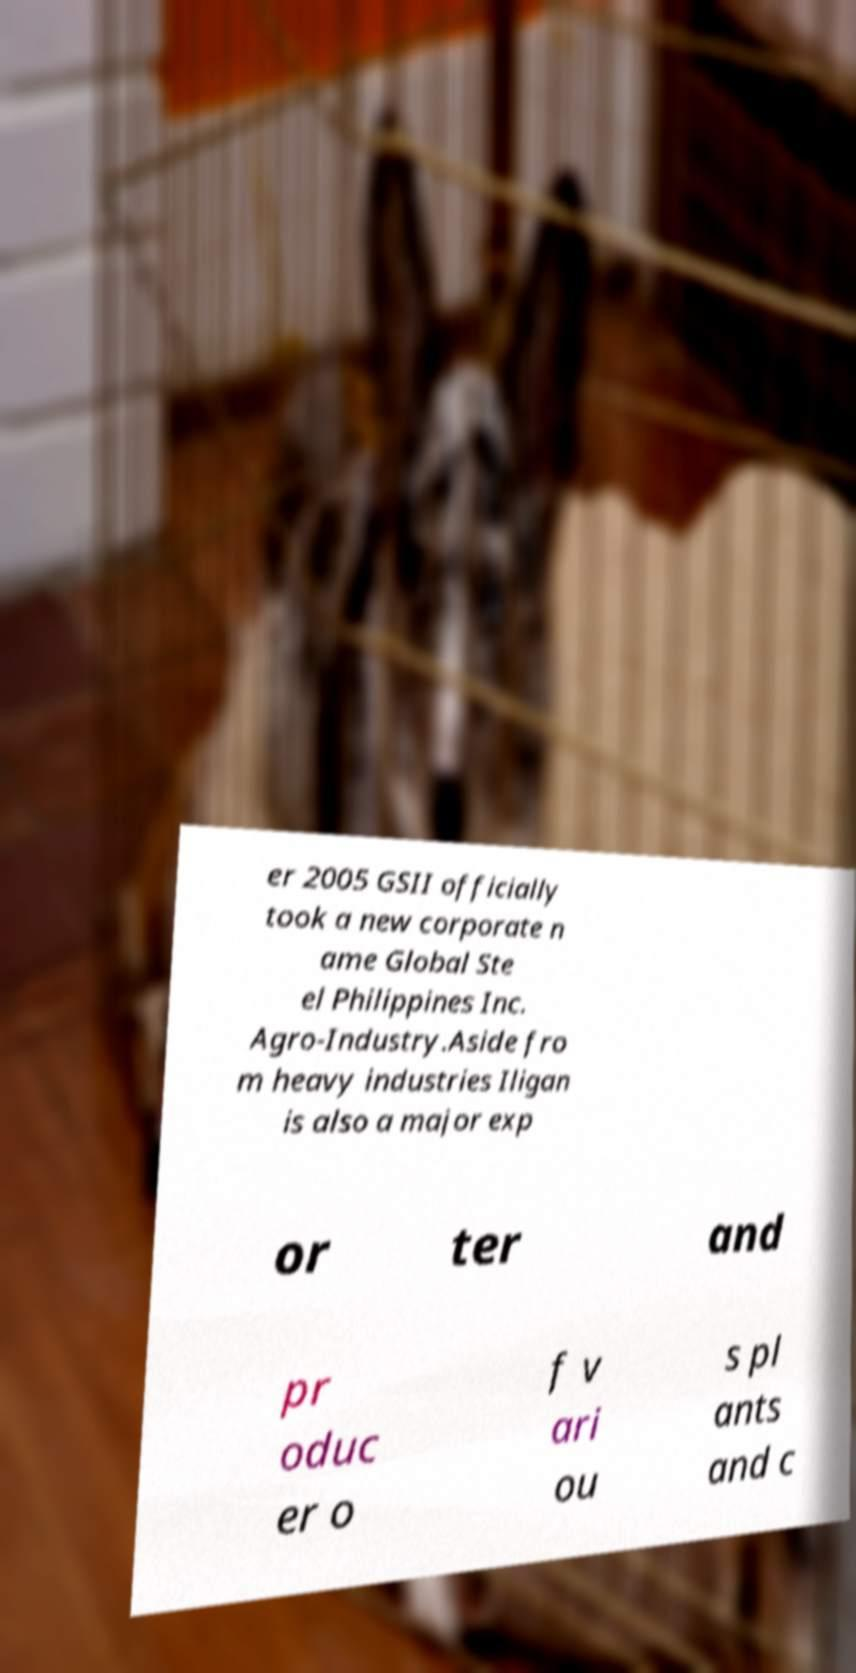Can you read and provide the text displayed in the image?This photo seems to have some interesting text. Can you extract and type it out for me? er 2005 GSII officially took a new corporate n ame Global Ste el Philippines Inc. Agro-Industry.Aside fro m heavy industries Iligan is also a major exp or ter and pr oduc er o f v ari ou s pl ants and c 